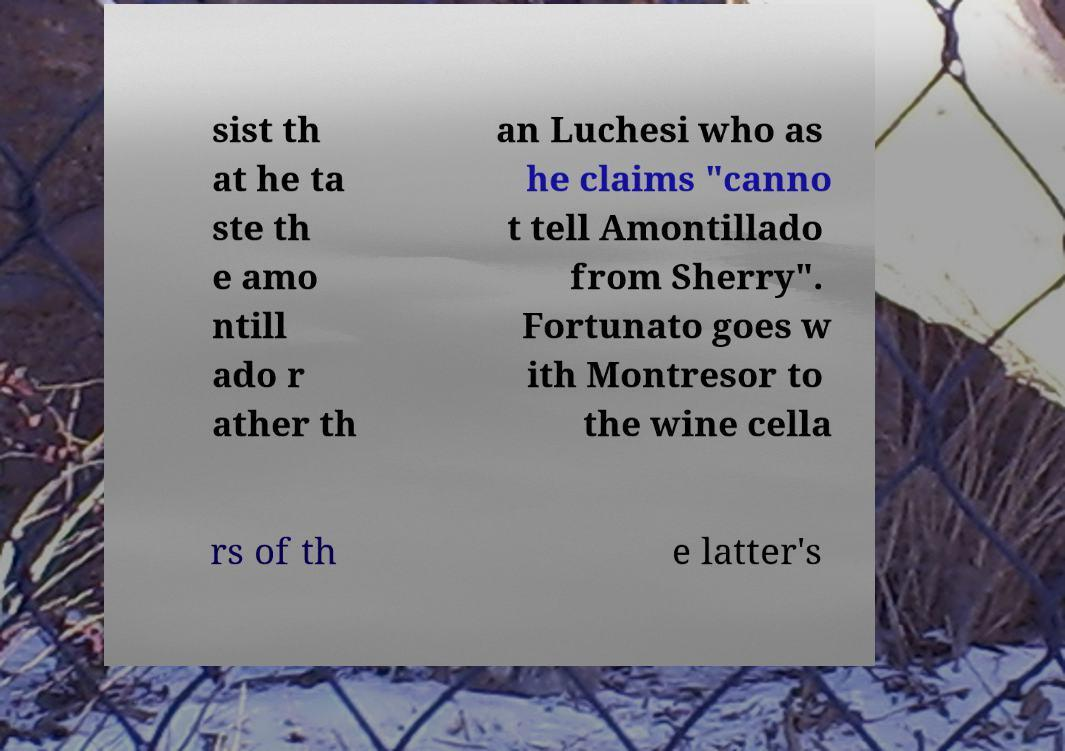Could you extract and type out the text from this image? sist th at he ta ste th e amo ntill ado r ather th an Luchesi who as he claims "canno t tell Amontillado from Sherry". Fortunato goes w ith Montresor to the wine cella rs of th e latter's 